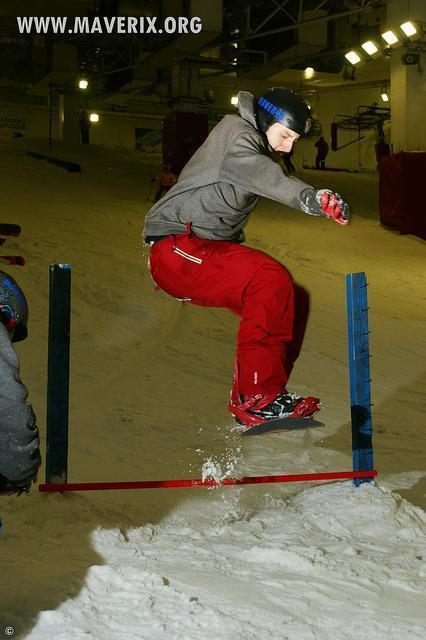How many people can you see?
Give a very brief answer. 2. 